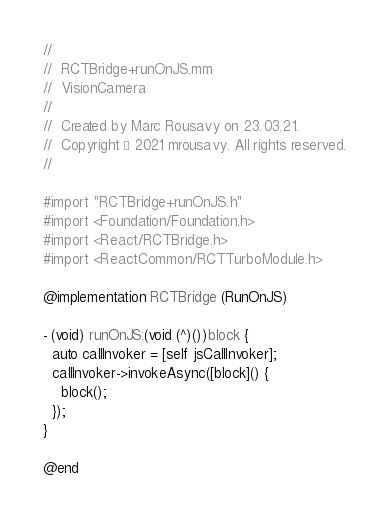Convert code to text. <code><loc_0><loc_0><loc_500><loc_500><_ObjectiveC_>//
//  RCTBridge+runOnJS.mm
//  VisionCamera
//
//  Created by Marc Rousavy on 23.03.21.
//  Copyright © 2021 mrousavy. All rights reserved.
//

#import "RCTBridge+runOnJS.h"
#import <Foundation/Foundation.h>
#import <React/RCTBridge.h>
#import <ReactCommon/RCTTurboModule.h>

@implementation RCTBridge (RunOnJS)

- (void) runOnJS:(void (^)())block {
  auto callInvoker = [self jsCallInvoker];
  callInvoker->invokeAsync([block]() {
    block();
  });
}

@end
</code> 